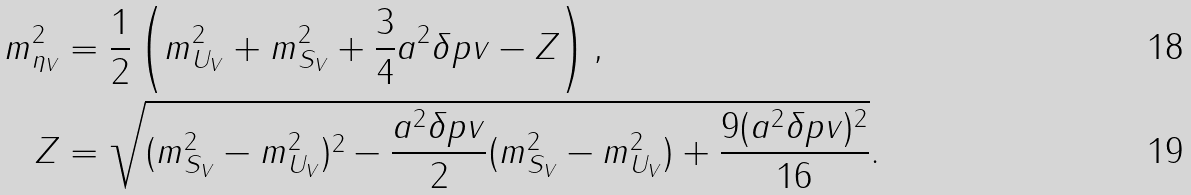Convert formula to latex. <formula><loc_0><loc_0><loc_500><loc_500>m ^ { 2 } _ { \eta _ { V } } & = \frac { 1 } { 2 } \left ( m ^ { 2 } _ { U _ { V } } + m ^ { 2 } _ { S _ { V } } + \frac { 3 } { 4 } a ^ { 2 } \delta p v - Z \right ) , \\ Z & = \sqrt { ( m ^ { 2 } _ { S _ { V } } - m ^ { 2 } _ { U _ { V } } ) ^ { 2 } - \frac { a ^ { 2 } \delta p v } { 2 } ( m ^ { 2 } _ { S _ { V } } - m ^ { 2 } _ { U _ { V } } ) + \frac { 9 ( a ^ { 2 } \delta p v ) ^ { 2 } } { 1 6 } } .</formula> 